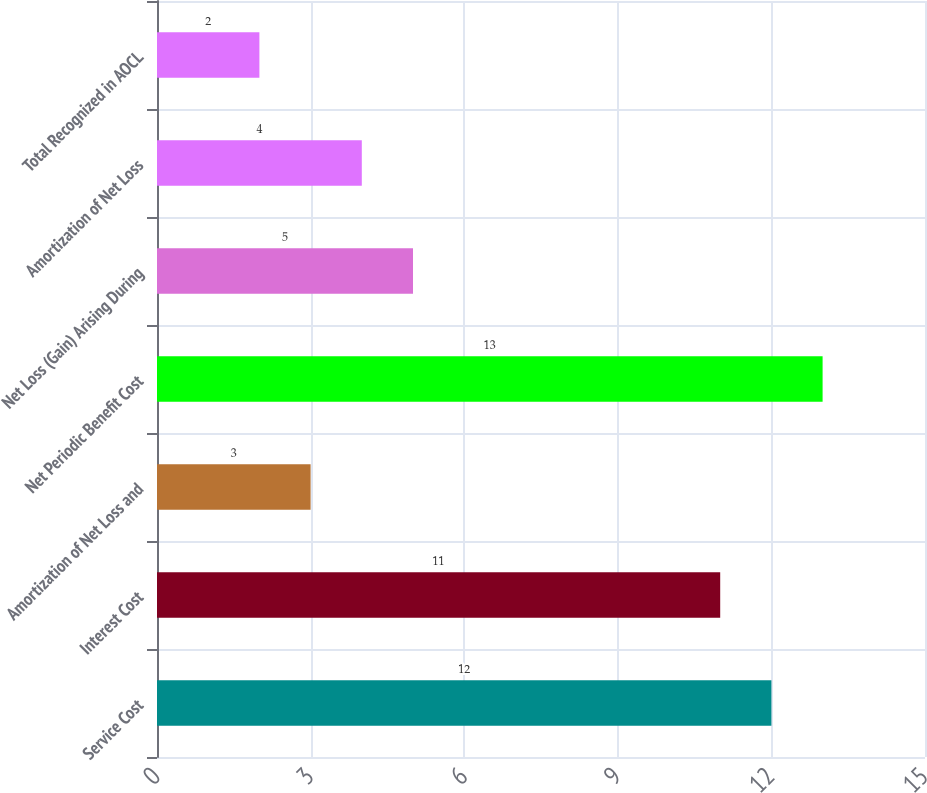Convert chart to OTSL. <chart><loc_0><loc_0><loc_500><loc_500><bar_chart><fcel>Service Cost<fcel>Interest Cost<fcel>Amortization of Net Loss and<fcel>Net Periodic Benefit Cost<fcel>Net Loss (Gain) Arising During<fcel>Amortization of Net Loss<fcel>Total Recognized in AOCL<nl><fcel>12<fcel>11<fcel>3<fcel>13<fcel>5<fcel>4<fcel>2<nl></chart> 